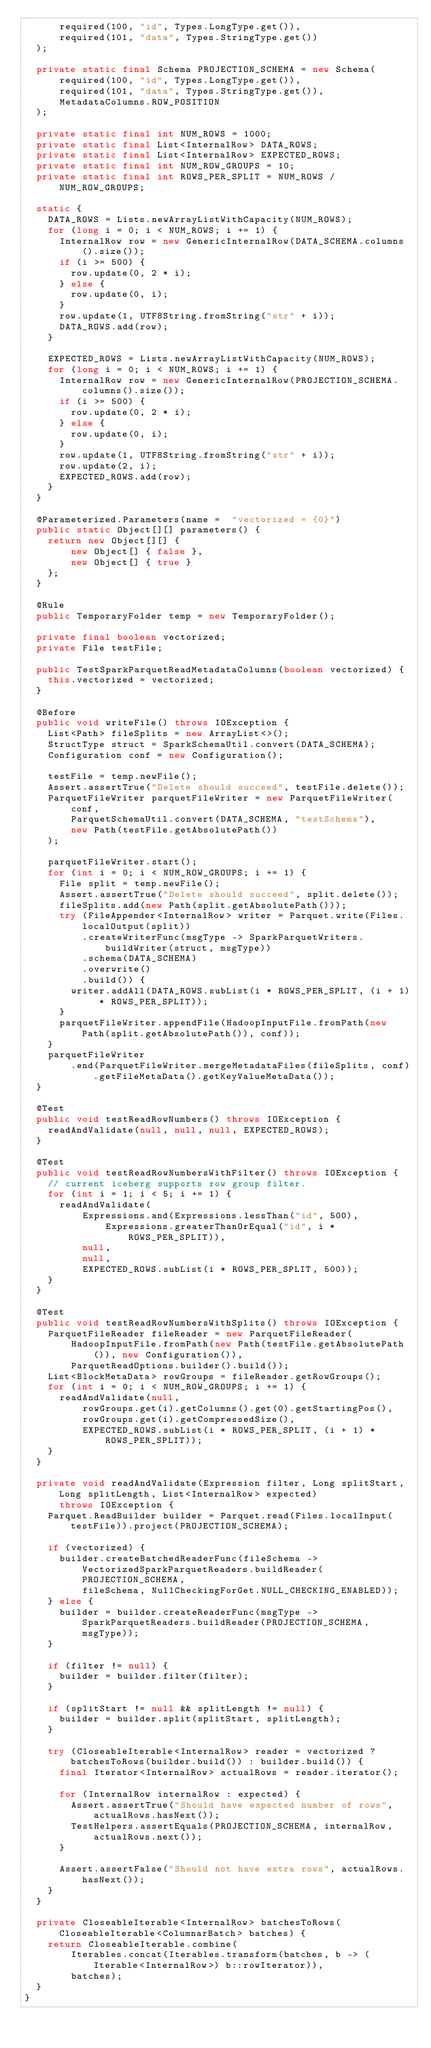<code> <loc_0><loc_0><loc_500><loc_500><_Java_>      required(100, "id", Types.LongType.get()),
      required(101, "data", Types.StringType.get())
  );

  private static final Schema PROJECTION_SCHEMA = new Schema(
      required(100, "id", Types.LongType.get()),
      required(101, "data", Types.StringType.get()),
      MetadataColumns.ROW_POSITION
  );

  private static final int NUM_ROWS = 1000;
  private static final List<InternalRow> DATA_ROWS;
  private static final List<InternalRow> EXPECTED_ROWS;
  private static final int NUM_ROW_GROUPS = 10;
  private static final int ROWS_PER_SPLIT = NUM_ROWS / NUM_ROW_GROUPS;

  static {
    DATA_ROWS = Lists.newArrayListWithCapacity(NUM_ROWS);
    for (long i = 0; i < NUM_ROWS; i += 1) {
      InternalRow row = new GenericInternalRow(DATA_SCHEMA.columns().size());
      if (i >= 500) {
        row.update(0, 2 * i);
      } else {
        row.update(0, i);
      }
      row.update(1, UTF8String.fromString("str" + i));
      DATA_ROWS.add(row);
    }

    EXPECTED_ROWS = Lists.newArrayListWithCapacity(NUM_ROWS);
    for (long i = 0; i < NUM_ROWS; i += 1) {
      InternalRow row = new GenericInternalRow(PROJECTION_SCHEMA.columns().size());
      if (i >= 500) {
        row.update(0, 2 * i);
      } else {
        row.update(0, i);
      }
      row.update(1, UTF8String.fromString("str" + i));
      row.update(2, i);
      EXPECTED_ROWS.add(row);
    }
  }

  @Parameterized.Parameters(name =  "vectorized = {0}")
  public static Object[][] parameters() {
    return new Object[][] {
        new Object[] { false },
        new Object[] { true }
    };
  }

  @Rule
  public TemporaryFolder temp = new TemporaryFolder();

  private final boolean vectorized;
  private File testFile;

  public TestSparkParquetReadMetadataColumns(boolean vectorized) {
    this.vectorized = vectorized;
  }

  @Before
  public void writeFile() throws IOException {
    List<Path> fileSplits = new ArrayList<>();
    StructType struct = SparkSchemaUtil.convert(DATA_SCHEMA);
    Configuration conf = new Configuration();

    testFile = temp.newFile();
    Assert.assertTrue("Delete should succeed", testFile.delete());
    ParquetFileWriter parquetFileWriter = new ParquetFileWriter(
        conf,
        ParquetSchemaUtil.convert(DATA_SCHEMA, "testSchema"),
        new Path(testFile.getAbsolutePath())
    );

    parquetFileWriter.start();
    for (int i = 0; i < NUM_ROW_GROUPS; i += 1) {
      File split = temp.newFile();
      Assert.assertTrue("Delete should succeed", split.delete());
      fileSplits.add(new Path(split.getAbsolutePath()));
      try (FileAppender<InternalRow> writer = Parquet.write(Files.localOutput(split))
          .createWriterFunc(msgType -> SparkParquetWriters.buildWriter(struct, msgType))
          .schema(DATA_SCHEMA)
          .overwrite()
          .build()) {
        writer.addAll(DATA_ROWS.subList(i * ROWS_PER_SPLIT, (i + 1) * ROWS_PER_SPLIT));
      }
      parquetFileWriter.appendFile(HadoopInputFile.fromPath(new Path(split.getAbsolutePath()), conf));
    }
    parquetFileWriter
        .end(ParquetFileWriter.mergeMetadataFiles(fileSplits, conf).getFileMetaData().getKeyValueMetaData());
  }

  @Test
  public void testReadRowNumbers() throws IOException {
    readAndValidate(null, null, null, EXPECTED_ROWS);
  }

  @Test
  public void testReadRowNumbersWithFilter() throws IOException {
    // current iceberg supports row group filter.
    for (int i = 1; i < 5; i += 1) {
      readAndValidate(
          Expressions.and(Expressions.lessThan("id", 500),
              Expressions.greaterThanOrEqual("id", i * ROWS_PER_SPLIT)),
          null,
          null,
          EXPECTED_ROWS.subList(i * ROWS_PER_SPLIT, 500));
    }
  }

  @Test
  public void testReadRowNumbersWithSplits() throws IOException {
    ParquetFileReader fileReader = new ParquetFileReader(
        HadoopInputFile.fromPath(new Path(testFile.getAbsolutePath()), new Configuration()),
        ParquetReadOptions.builder().build());
    List<BlockMetaData> rowGroups = fileReader.getRowGroups();
    for (int i = 0; i < NUM_ROW_GROUPS; i += 1) {
      readAndValidate(null,
          rowGroups.get(i).getColumns().get(0).getStartingPos(),
          rowGroups.get(i).getCompressedSize(),
          EXPECTED_ROWS.subList(i * ROWS_PER_SPLIT, (i + 1) * ROWS_PER_SPLIT));
    }
  }

  private void readAndValidate(Expression filter, Long splitStart, Long splitLength, List<InternalRow> expected)
      throws IOException {
    Parquet.ReadBuilder builder = Parquet.read(Files.localInput(testFile)).project(PROJECTION_SCHEMA);

    if (vectorized) {
      builder.createBatchedReaderFunc(fileSchema -> VectorizedSparkParquetReaders.buildReader(PROJECTION_SCHEMA,
          fileSchema, NullCheckingForGet.NULL_CHECKING_ENABLED));
    } else {
      builder = builder.createReaderFunc(msgType -> SparkParquetReaders.buildReader(PROJECTION_SCHEMA, msgType));
    }

    if (filter != null) {
      builder = builder.filter(filter);
    }

    if (splitStart != null && splitLength != null) {
      builder = builder.split(splitStart, splitLength);
    }

    try (CloseableIterable<InternalRow> reader = vectorized ? batchesToRows(builder.build()) : builder.build()) {
      final Iterator<InternalRow> actualRows = reader.iterator();

      for (InternalRow internalRow : expected) {
        Assert.assertTrue("Should have expected number of rows", actualRows.hasNext());
        TestHelpers.assertEquals(PROJECTION_SCHEMA, internalRow, actualRows.next());
      }

      Assert.assertFalse("Should not have extra rows", actualRows.hasNext());
    }
  }

  private CloseableIterable<InternalRow> batchesToRows(CloseableIterable<ColumnarBatch> batches) {
    return CloseableIterable.combine(
        Iterables.concat(Iterables.transform(batches, b -> (Iterable<InternalRow>) b::rowIterator)),
        batches);
  }
}
</code> 